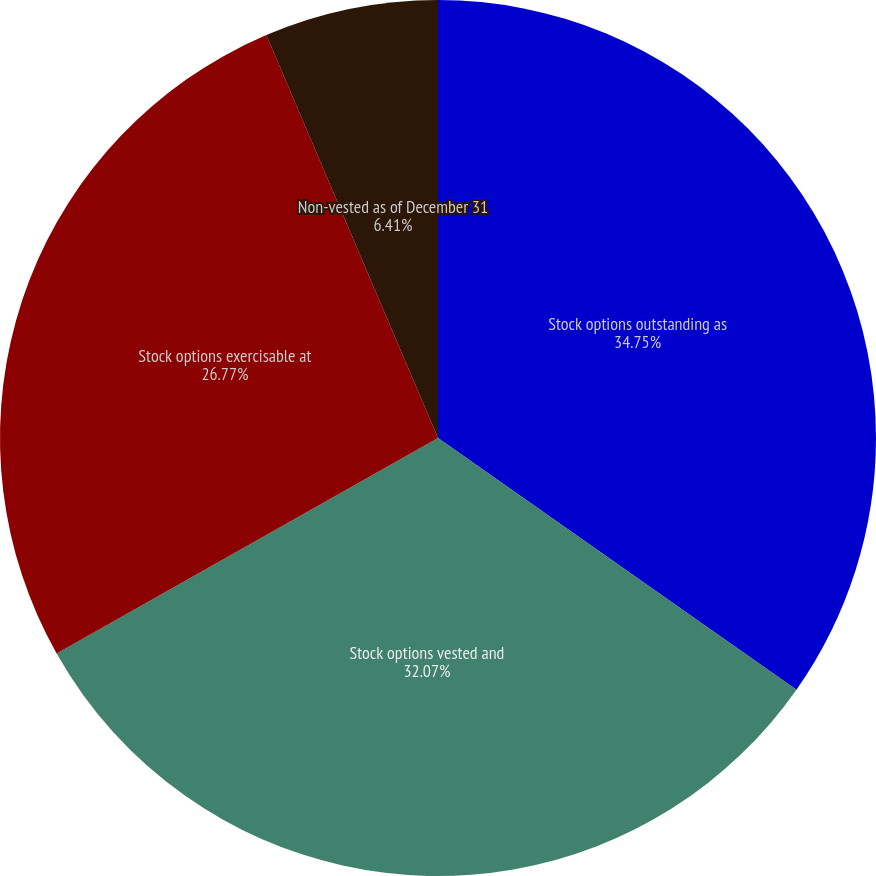Convert chart to OTSL. <chart><loc_0><loc_0><loc_500><loc_500><pie_chart><fcel>Stock options outstanding as<fcel>Stock options vested and<fcel>Stock options exercisable at<fcel>Non-vested as of December 31<nl><fcel>34.74%<fcel>32.07%<fcel>26.77%<fcel>6.41%<nl></chart> 